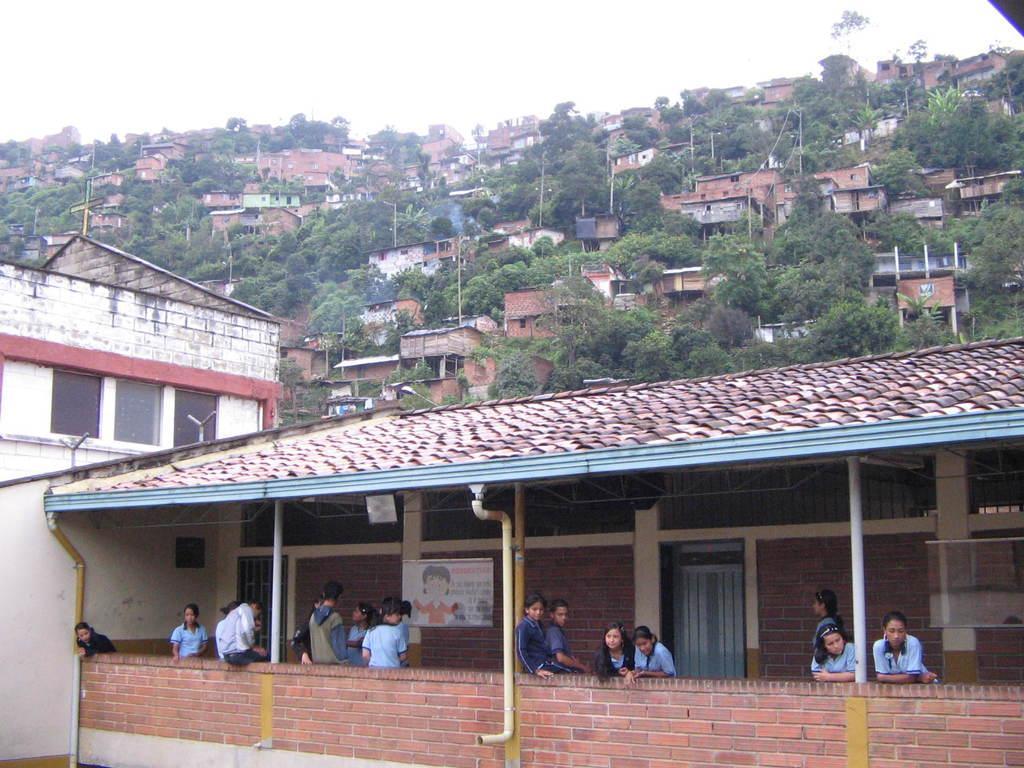Describe this image in one or two sentences. In this picture we can see some people, poster on the wall, pipes, buildings, trees, some objects and in the background we can see the sky. 